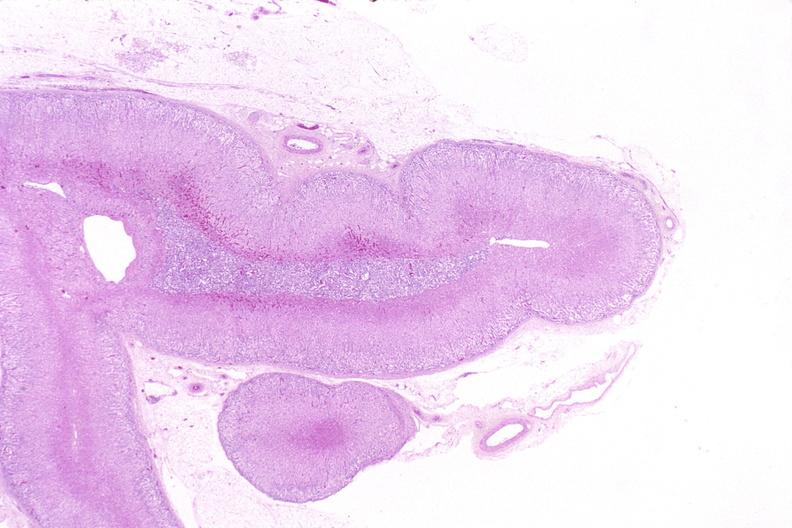what is present?
Answer the question using a single word or phrase. Endocrine 